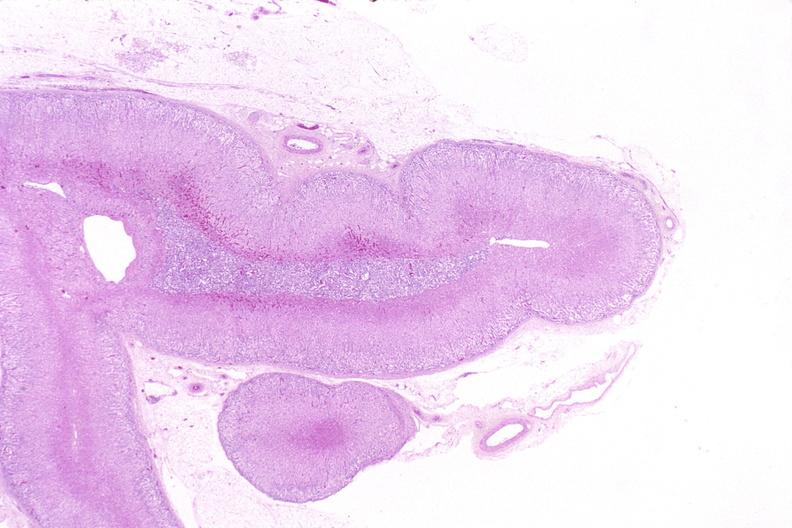what is present?
Answer the question using a single word or phrase. Endocrine 